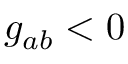<formula> <loc_0><loc_0><loc_500><loc_500>g _ { a b } < 0</formula> 